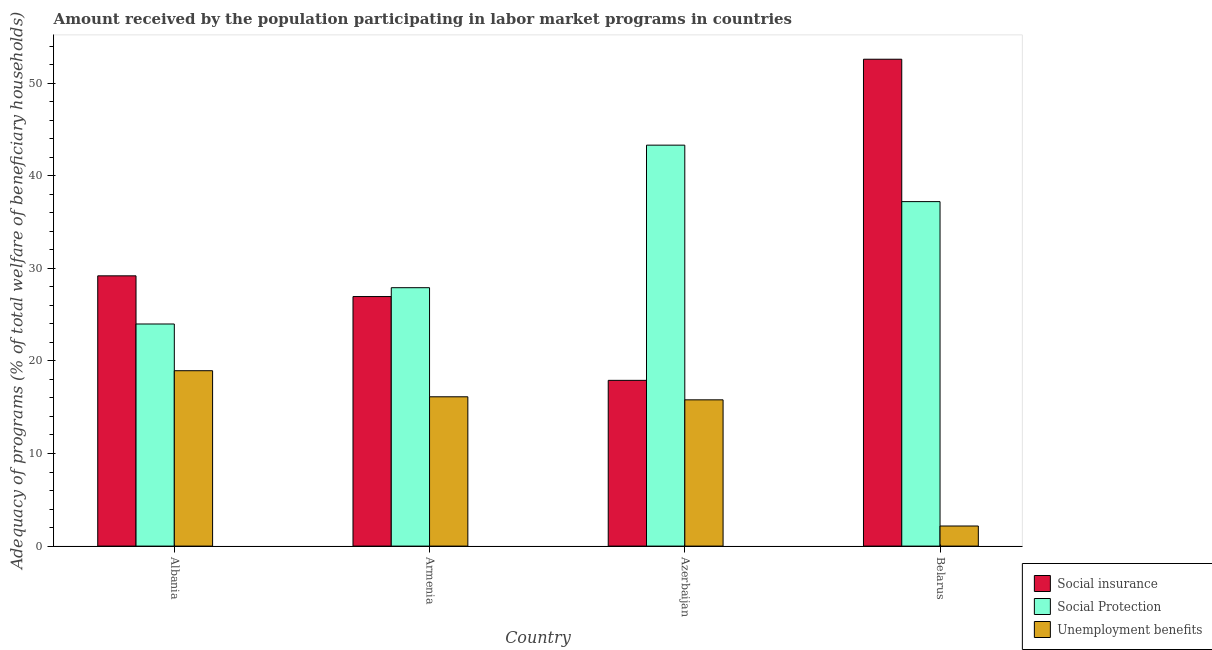How many different coloured bars are there?
Offer a terse response. 3. Are the number of bars on each tick of the X-axis equal?
Ensure brevity in your answer.  Yes. What is the label of the 4th group of bars from the left?
Offer a very short reply. Belarus. What is the amount received by the population participating in social insurance programs in Azerbaijan?
Your answer should be very brief. 17.9. Across all countries, what is the maximum amount received by the population participating in social insurance programs?
Your answer should be very brief. 52.58. Across all countries, what is the minimum amount received by the population participating in social insurance programs?
Your answer should be very brief. 17.9. In which country was the amount received by the population participating in social protection programs maximum?
Offer a terse response. Azerbaijan. In which country was the amount received by the population participating in social insurance programs minimum?
Give a very brief answer. Azerbaijan. What is the total amount received by the population participating in social protection programs in the graph?
Provide a succinct answer. 132.39. What is the difference between the amount received by the population participating in social protection programs in Azerbaijan and that in Belarus?
Ensure brevity in your answer.  6.1. What is the difference between the amount received by the population participating in unemployment benefits programs in Albania and the amount received by the population participating in social insurance programs in Azerbaijan?
Your answer should be compact. 1.04. What is the average amount received by the population participating in social protection programs per country?
Provide a short and direct response. 33.1. What is the difference between the amount received by the population participating in social insurance programs and amount received by the population participating in social protection programs in Azerbaijan?
Offer a terse response. -25.4. What is the ratio of the amount received by the population participating in unemployment benefits programs in Armenia to that in Azerbaijan?
Your answer should be compact. 1.02. What is the difference between the highest and the second highest amount received by the population participating in unemployment benefits programs?
Give a very brief answer. 2.82. What is the difference between the highest and the lowest amount received by the population participating in social insurance programs?
Your answer should be compact. 34.68. What does the 1st bar from the left in Albania represents?
Your answer should be compact. Social insurance. What does the 1st bar from the right in Albania represents?
Your answer should be very brief. Unemployment benefits. Are all the bars in the graph horizontal?
Offer a very short reply. No. What is the difference between two consecutive major ticks on the Y-axis?
Your answer should be compact. 10. Are the values on the major ticks of Y-axis written in scientific E-notation?
Your response must be concise. No. Does the graph contain grids?
Your answer should be very brief. No. How are the legend labels stacked?
Give a very brief answer. Vertical. What is the title of the graph?
Make the answer very short. Amount received by the population participating in labor market programs in countries. Does "Poland" appear as one of the legend labels in the graph?
Your response must be concise. No. What is the label or title of the X-axis?
Offer a very short reply. Country. What is the label or title of the Y-axis?
Provide a succinct answer. Adequacy of programs (% of total welfare of beneficiary households). What is the Adequacy of programs (% of total welfare of beneficiary households) in Social insurance in Albania?
Your response must be concise. 29.19. What is the Adequacy of programs (% of total welfare of beneficiary households) of Social Protection in Albania?
Your response must be concise. 23.99. What is the Adequacy of programs (% of total welfare of beneficiary households) in Unemployment benefits in Albania?
Provide a short and direct response. 18.94. What is the Adequacy of programs (% of total welfare of beneficiary households) in Social insurance in Armenia?
Offer a terse response. 26.95. What is the Adequacy of programs (% of total welfare of beneficiary households) in Social Protection in Armenia?
Ensure brevity in your answer.  27.91. What is the Adequacy of programs (% of total welfare of beneficiary households) in Unemployment benefits in Armenia?
Ensure brevity in your answer.  16.12. What is the Adequacy of programs (% of total welfare of beneficiary households) of Social insurance in Azerbaijan?
Your answer should be compact. 17.9. What is the Adequacy of programs (% of total welfare of beneficiary households) of Social Protection in Azerbaijan?
Your answer should be very brief. 43.3. What is the Adequacy of programs (% of total welfare of beneficiary households) in Unemployment benefits in Azerbaijan?
Provide a succinct answer. 15.8. What is the Adequacy of programs (% of total welfare of beneficiary households) in Social insurance in Belarus?
Give a very brief answer. 52.58. What is the Adequacy of programs (% of total welfare of beneficiary households) in Social Protection in Belarus?
Ensure brevity in your answer.  37.2. What is the Adequacy of programs (% of total welfare of beneficiary households) of Unemployment benefits in Belarus?
Give a very brief answer. 2.17. Across all countries, what is the maximum Adequacy of programs (% of total welfare of beneficiary households) in Social insurance?
Your answer should be very brief. 52.58. Across all countries, what is the maximum Adequacy of programs (% of total welfare of beneficiary households) in Social Protection?
Your answer should be very brief. 43.3. Across all countries, what is the maximum Adequacy of programs (% of total welfare of beneficiary households) in Unemployment benefits?
Provide a succinct answer. 18.94. Across all countries, what is the minimum Adequacy of programs (% of total welfare of beneficiary households) of Social insurance?
Provide a succinct answer. 17.9. Across all countries, what is the minimum Adequacy of programs (% of total welfare of beneficiary households) of Social Protection?
Provide a succinct answer. 23.99. Across all countries, what is the minimum Adequacy of programs (% of total welfare of beneficiary households) in Unemployment benefits?
Make the answer very short. 2.17. What is the total Adequacy of programs (% of total welfare of beneficiary households) in Social insurance in the graph?
Keep it short and to the point. 126.61. What is the total Adequacy of programs (% of total welfare of beneficiary households) in Social Protection in the graph?
Keep it short and to the point. 132.39. What is the total Adequacy of programs (% of total welfare of beneficiary households) in Unemployment benefits in the graph?
Your response must be concise. 53.03. What is the difference between the Adequacy of programs (% of total welfare of beneficiary households) in Social insurance in Albania and that in Armenia?
Provide a succinct answer. 2.24. What is the difference between the Adequacy of programs (% of total welfare of beneficiary households) of Social Protection in Albania and that in Armenia?
Your response must be concise. -3.92. What is the difference between the Adequacy of programs (% of total welfare of beneficiary households) of Unemployment benefits in Albania and that in Armenia?
Provide a short and direct response. 2.82. What is the difference between the Adequacy of programs (% of total welfare of beneficiary households) in Social insurance in Albania and that in Azerbaijan?
Your answer should be compact. 11.29. What is the difference between the Adequacy of programs (% of total welfare of beneficiary households) in Social Protection in Albania and that in Azerbaijan?
Your response must be concise. -19.31. What is the difference between the Adequacy of programs (% of total welfare of beneficiary households) in Unemployment benefits in Albania and that in Azerbaijan?
Ensure brevity in your answer.  3.15. What is the difference between the Adequacy of programs (% of total welfare of beneficiary households) in Social insurance in Albania and that in Belarus?
Ensure brevity in your answer.  -23.39. What is the difference between the Adequacy of programs (% of total welfare of beneficiary households) in Social Protection in Albania and that in Belarus?
Your answer should be very brief. -13.22. What is the difference between the Adequacy of programs (% of total welfare of beneficiary households) of Unemployment benefits in Albania and that in Belarus?
Give a very brief answer. 16.77. What is the difference between the Adequacy of programs (% of total welfare of beneficiary households) of Social insurance in Armenia and that in Azerbaijan?
Offer a very short reply. 9.05. What is the difference between the Adequacy of programs (% of total welfare of beneficiary households) in Social Protection in Armenia and that in Azerbaijan?
Offer a very short reply. -15.39. What is the difference between the Adequacy of programs (% of total welfare of beneficiary households) of Unemployment benefits in Armenia and that in Azerbaijan?
Your response must be concise. 0.33. What is the difference between the Adequacy of programs (% of total welfare of beneficiary households) in Social insurance in Armenia and that in Belarus?
Provide a short and direct response. -25.63. What is the difference between the Adequacy of programs (% of total welfare of beneficiary households) in Social Protection in Armenia and that in Belarus?
Provide a short and direct response. -9.3. What is the difference between the Adequacy of programs (% of total welfare of beneficiary households) of Unemployment benefits in Armenia and that in Belarus?
Offer a very short reply. 13.95. What is the difference between the Adequacy of programs (% of total welfare of beneficiary households) of Social insurance in Azerbaijan and that in Belarus?
Your answer should be very brief. -34.68. What is the difference between the Adequacy of programs (% of total welfare of beneficiary households) in Social Protection in Azerbaijan and that in Belarus?
Make the answer very short. 6.1. What is the difference between the Adequacy of programs (% of total welfare of beneficiary households) in Unemployment benefits in Azerbaijan and that in Belarus?
Provide a short and direct response. 13.62. What is the difference between the Adequacy of programs (% of total welfare of beneficiary households) in Social insurance in Albania and the Adequacy of programs (% of total welfare of beneficiary households) in Social Protection in Armenia?
Offer a very short reply. 1.28. What is the difference between the Adequacy of programs (% of total welfare of beneficiary households) in Social insurance in Albania and the Adequacy of programs (% of total welfare of beneficiary households) in Unemployment benefits in Armenia?
Offer a very short reply. 13.06. What is the difference between the Adequacy of programs (% of total welfare of beneficiary households) of Social Protection in Albania and the Adequacy of programs (% of total welfare of beneficiary households) of Unemployment benefits in Armenia?
Your answer should be very brief. 7.86. What is the difference between the Adequacy of programs (% of total welfare of beneficiary households) in Social insurance in Albania and the Adequacy of programs (% of total welfare of beneficiary households) in Social Protection in Azerbaijan?
Provide a succinct answer. -14.11. What is the difference between the Adequacy of programs (% of total welfare of beneficiary households) of Social insurance in Albania and the Adequacy of programs (% of total welfare of beneficiary households) of Unemployment benefits in Azerbaijan?
Provide a short and direct response. 13.39. What is the difference between the Adequacy of programs (% of total welfare of beneficiary households) in Social Protection in Albania and the Adequacy of programs (% of total welfare of beneficiary households) in Unemployment benefits in Azerbaijan?
Your answer should be very brief. 8.19. What is the difference between the Adequacy of programs (% of total welfare of beneficiary households) in Social insurance in Albania and the Adequacy of programs (% of total welfare of beneficiary households) in Social Protection in Belarus?
Provide a succinct answer. -8.01. What is the difference between the Adequacy of programs (% of total welfare of beneficiary households) of Social insurance in Albania and the Adequacy of programs (% of total welfare of beneficiary households) of Unemployment benefits in Belarus?
Your answer should be compact. 27.02. What is the difference between the Adequacy of programs (% of total welfare of beneficiary households) in Social Protection in Albania and the Adequacy of programs (% of total welfare of beneficiary households) in Unemployment benefits in Belarus?
Your response must be concise. 21.82. What is the difference between the Adequacy of programs (% of total welfare of beneficiary households) in Social insurance in Armenia and the Adequacy of programs (% of total welfare of beneficiary households) in Social Protection in Azerbaijan?
Provide a short and direct response. -16.35. What is the difference between the Adequacy of programs (% of total welfare of beneficiary households) in Social insurance in Armenia and the Adequacy of programs (% of total welfare of beneficiary households) in Unemployment benefits in Azerbaijan?
Ensure brevity in your answer.  11.15. What is the difference between the Adequacy of programs (% of total welfare of beneficiary households) of Social Protection in Armenia and the Adequacy of programs (% of total welfare of beneficiary households) of Unemployment benefits in Azerbaijan?
Provide a succinct answer. 12.11. What is the difference between the Adequacy of programs (% of total welfare of beneficiary households) in Social insurance in Armenia and the Adequacy of programs (% of total welfare of beneficiary households) in Social Protection in Belarus?
Give a very brief answer. -10.25. What is the difference between the Adequacy of programs (% of total welfare of beneficiary households) in Social insurance in Armenia and the Adequacy of programs (% of total welfare of beneficiary households) in Unemployment benefits in Belarus?
Make the answer very short. 24.78. What is the difference between the Adequacy of programs (% of total welfare of beneficiary households) in Social Protection in Armenia and the Adequacy of programs (% of total welfare of beneficiary households) in Unemployment benefits in Belarus?
Keep it short and to the point. 25.74. What is the difference between the Adequacy of programs (% of total welfare of beneficiary households) of Social insurance in Azerbaijan and the Adequacy of programs (% of total welfare of beneficiary households) of Social Protection in Belarus?
Your answer should be very brief. -19.3. What is the difference between the Adequacy of programs (% of total welfare of beneficiary households) in Social insurance in Azerbaijan and the Adequacy of programs (% of total welfare of beneficiary households) in Unemployment benefits in Belarus?
Provide a succinct answer. 15.73. What is the difference between the Adequacy of programs (% of total welfare of beneficiary households) of Social Protection in Azerbaijan and the Adequacy of programs (% of total welfare of beneficiary households) of Unemployment benefits in Belarus?
Provide a short and direct response. 41.13. What is the average Adequacy of programs (% of total welfare of beneficiary households) in Social insurance per country?
Provide a short and direct response. 31.65. What is the average Adequacy of programs (% of total welfare of beneficiary households) of Social Protection per country?
Your answer should be very brief. 33.1. What is the average Adequacy of programs (% of total welfare of beneficiary households) of Unemployment benefits per country?
Provide a short and direct response. 13.26. What is the difference between the Adequacy of programs (% of total welfare of beneficiary households) in Social insurance and Adequacy of programs (% of total welfare of beneficiary households) in Social Protection in Albania?
Provide a succinct answer. 5.2. What is the difference between the Adequacy of programs (% of total welfare of beneficiary households) in Social insurance and Adequacy of programs (% of total welfare of beneficiary households) in Unemployment benefits in Albania?
Offer a terse response. 10.24. What is the difference between the Adequacy of programs (% of total welfare of beneficiary households) in Social Protection and Adequacy of programs (% of total welfare of beneficiary households) in Unemployment benefits in Albania?
Provide a short and direct response. 5.04. What is the difference between the Adequacy of programs (% of total welfare of beneficiary households) of Social insurance and Adequacy of programs (% of total welfare of beneficiary households) of Social Protection in Armenia?
Your answer should be very brief. -0.96. What is the difference between the Adequacy of programs (% of total welfare of beneficiary households) in Social insurance and Adequacy of programs (% of total welfare of beneficiary households) in Unemployment benefits in Armenia?
Offer a terse response. 10.82. What is the difference between the Adequacy of programs (% of total welfare of beneficiary households) of Social Protection and Adequacy of programs (% of total welfare of beneficiary households) of Unemployment benefits in Armenia?
Give a very brief answer. 11.78. What is the difference between the Adequacy of programs (% of total welfare of beneficiary households) of Social insurance and Adequacy of programs (% of total welfare of beneficiary households) of Social Protection in Azerbaijan?
Your answer should be very brief. -25.4. What is the difference between the Adequacy of programs (% of total welfare of beneficiary households) in Social insurance and Adequacy of programs (% of total welfare of beneficiary households) in Unemployment benefits in Azerbaijan?
Provide a short and direct response. 2.1. What is the difference between the Adequacy of programs (% of total welfare of beneficiary households) of Social Protection and Adequacy of programs (% of total welfare of beneficiary households) of Unemployment benefits in Azerbaijan?
Give a very brief answer. 27.5. What is the difference between the Adequacy of programs (% of total welfare of beneficiary households) of Social insurance and Adequacy of programs (% of total welfare of beneficiary households) of Social Protection in Belarus?
Your answer should be compact. 15.38. What is the difference between the Adequacy of programs (% of total welfare of beneficiary households) of Social insurance and Adequacy of programs (% of total welfare of beneficiary households) of Unemployment benefits in Belarus?
Your response must be concise. 50.41. What is the difference between the Adequacy of programs (% of total welfare of beneficiary households) in Social Protection and Adequacy of programs (% of total welfare of beneficiary households) in Unemployment benefits in Belarus?
Make the answer very short. 35.03. What is the ratio of the Adequacy of programs (% of total welfare of beneficiary households) of Social insurance in Albania to that in Armenia?
Your answer should be compact. 1.08. What is the ratio of the Adequacy of programs (% of total welfare of beneficiary households) in Social Protection in Albania to that in Armenia?
Provide a succinct answer. 0.86. What is the ratio of the Adequacy of programs (% of total welfare of beneficiary households) in Unemployment benefits in Albania to that in Armenia?
Offer a very short reply. 1.17. What is the ratio of the Adequacy of programs (% of total welfare of beneficiary households) of Social insurance in Albania to that in Azerbaijan?
Keep it short and to the point. 1.63. What is the ratio of the Adequacy of programs (% of total welfare of beneficiary households) in Social Protection in Albania to that in Azerbaijan?
Provide a short and direct response. 0.55. What is the ratio of the Adequacy of programs (% of total welfare of beneficiary households) of Unemployment benefits in Albania to that in Azerbaijan?
Your answer should be very brief. 1.2. What is the ratio of the Adequacy of programs (% of total welfare of beneficiary households) of Social insurance in Albania to that in Belarus?
Offer a very short reply. 0.56. What is the ratio of the Adequacy of programs (% of total welfare of beneficiary households) in Social Protection in Albania to that in Belarus?
Give a very brief answer. 0.64. What is the ratio of the Adequacy of programs (% of total welfare of beneficiary households) in Unemployment benefits in Albania to that in Belarus?
Make the answer very short. 8.73. What is the ratio of the Adequacy of programs (% of total welfare of beneficiary households) in Social insurance in Armenia to that in Azerbaijan?
Give a very brief answer. 1.51. What is the ratio of the Adequacy of programs (% of total welfare of beneficiary households) of Social Protection in Armenia to that in Azerbaijan?
Provide a succinct answer. 0.64. What is the ratio of the Adequacy of programs (% of total welfare of beneficiary households) in Unemployment benefits in Armenia to that in Azerbaijan?
Your answer should be very brief. 1.02. What is the ratio of the Adequacy of programs (% of total welfare of beneficiary households) of Social insurance in Armenia to that in Belarus?
Ensure brevity in your answer.  0.51. What is the ratio of the Adequacy of programs (% of total welfare of beneficiary households) in Social Protection in Armenia to that in Belarus?
Keep it short and to the point. 0.75. What is the ratio of the Adequacy of programs (% of total welfare of beneficiary households) in Unemployment benefits in Armenia to that in Belarus?
Provide a short and direct response. 7.43. What is the ratio of the Adequacy of programs (% of total welfare of beneficiary households) in Social insurance in Azerbaijan to that in Belarus?
Your response must be concise. 0.34. What is the ratio of the Adequacy of programs (% of total welfare of beneficiary households) in Social Protection in Azerbaijan to that in Belarus?
Give a very brief answer. 1.16. What is the ratio of the Adequacy of programs (% of total welfare of beneficiary households) in Unemployment benefits in Azerbaijan to that in Belarus?
Offer a terse response. 7.28. What is the difference between the highest and the second highest Adequacy of programs (% of total welfare of beneficiary households) in Social insurance?
Provide a short and direct response. 23.39. What is the difference between the highest and the second highest Adequacy of programs (% of total welfare of beneficiary households) of Social Protection?
Provide a short and direct response. 6.1. What is the difference between the highest and the second highest Adequacy of programs (% of total welfare of beneficiary households) in Unemployment benefits?
Provide a short and direct response. 2.82. What is the difference between the highest and the lowest Adequacy of programs (% of total welfare of beneficiary households) in Social insurance?
Make the answer very short. 34.68. What is the difference between the highest and the lowest Adequacy of programs (% of total welfare of beneficiary households) in Social Protection?
Provide a succinct answer. 19.31. What is the difference between the highest and the lowest Adequacy of programs (% of total welfare of beneficiary households) of Unemployment benefits?
Ensure brevity in your answer.  16.77. 